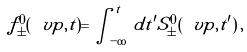<formula> <loc_0><loc_0><loc_500><loc_500>f ^ { 0 } _ { \pm } ( \ v p , t ) = \int _ { - \infty } ^ { \, t } \, d t ^ { \prime } S _ { \pm } ^ { 0 } ( \ v p , t ^ { \prime } ) \, ,</formula> 